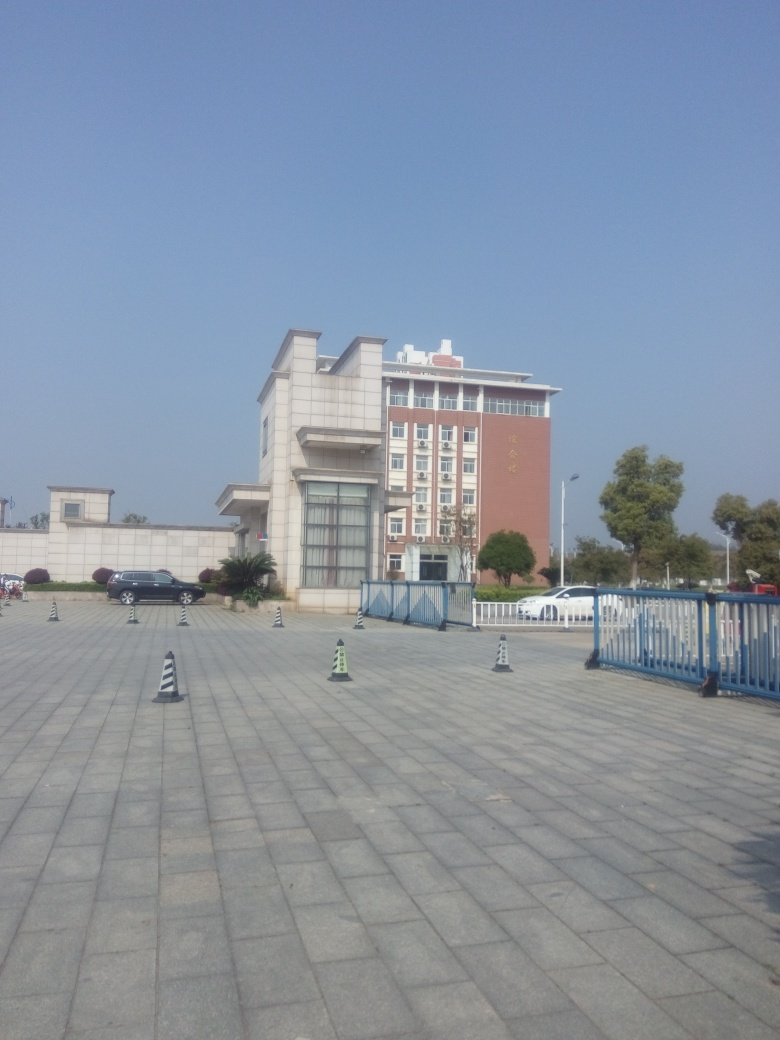Does the image highlight the focus well?
A. Yes
B. No
Answer with the option's letter from the given choices directly.
 A. 